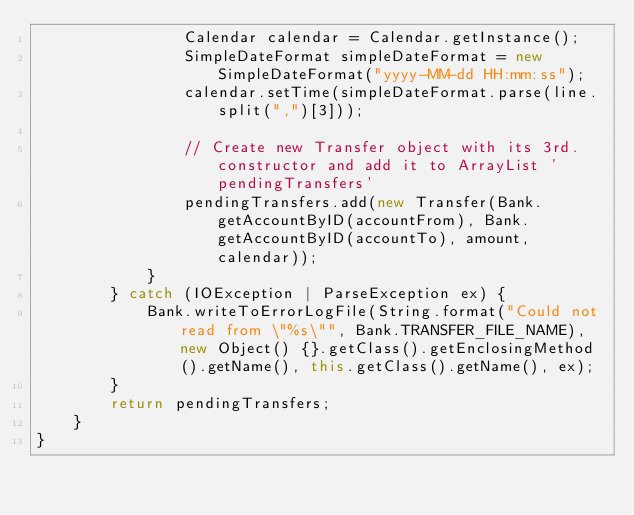<code> <loc_0><loc_0><loc_500><loc_500><_Java_>                Calendar calendar = Calendar.getInstance();
                SimpleDateFormat simpleDateFormat = new SimpleDateFormat("yyyy-MM-dd HH:mm:ss");
                calendar.setTime(simpleDateFormat.parse(line.split(",")[3]));

                // Create new Transfer object with its 3rd. constructor and add it to ArrayList 'pendingTransfers'
                pendingTransfers.add(new Transfer(Bank.getAccountByID(accountFrom), Bank.getAccountByID(accountTo), amount, calendar));
            }
        } catch (IOException | ParseException ex) {
            Bank.writeToErrorLogFile(String.format("Could not read from \"%s\"", Bank.TRANSFER_FILE_NAME), new Object() {}.getClass().getEnclosingMethod().getName(), this.getClass().getName(), ex);
        }
        return pendingTransfers;
    }
}</code> 